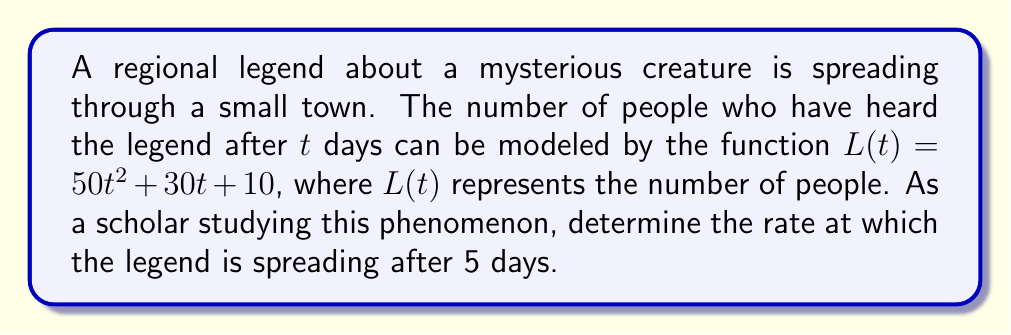Show me your answer to this math problem. To find the rate at which the legend is spreading after 5 days, we need to calculate the derivative of $L(t)$ and evaluate it at $t=5$. This will give us the instantaneous rate of change at that point.

Step 1: Find the derivative of $L(t)$.
$$L(t) = 50t^2 + 30t + 10$$
$$L'(t) = 100t + 30$$

Step 2: Evaluate $L'(t)$ at $t=5$.
$$L'(5) = 100(5) + 30$$
$$L'(5) = 500 + 30$$
$$L'(5) = 530$$

Therefore, after 5 days, the legend is spreading at a rate of 530 people per day.
Answer: 530 people/day 